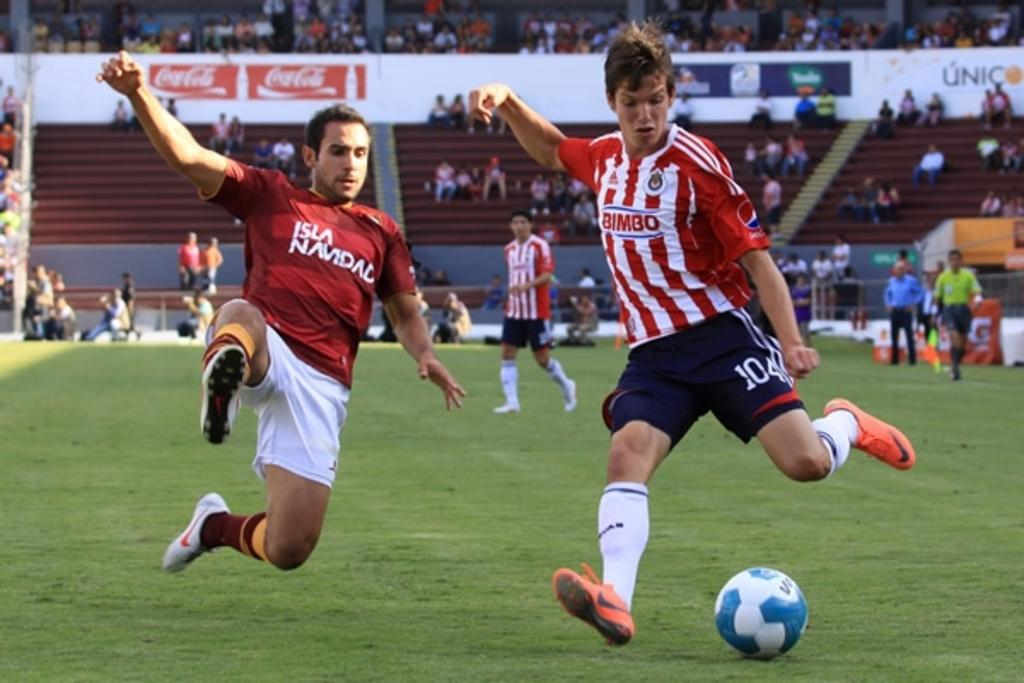What are the people in the image doing? The people in the image are playing on the ground. What is the surface they are playing on? The ground is covered with grass. What object is being used in their game? There is a ball present. What can be seen in the background of the image? There are hoardings and a crowd in the background. What type of pear is being served to the governor in the image? There is no pear or governor present in the image. How much butter is being used by the crowd in the background? There is no butter mentioned or visible in the image. 